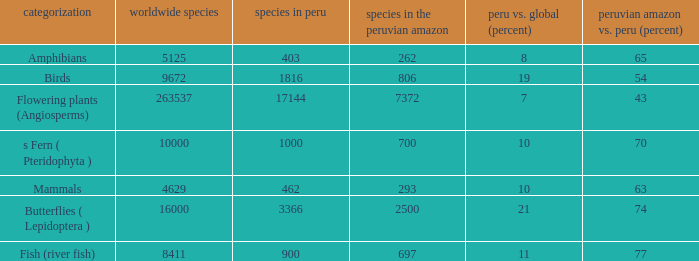What's the maximum peru vs. world (percent) with 9672 species in the world  19.0. 